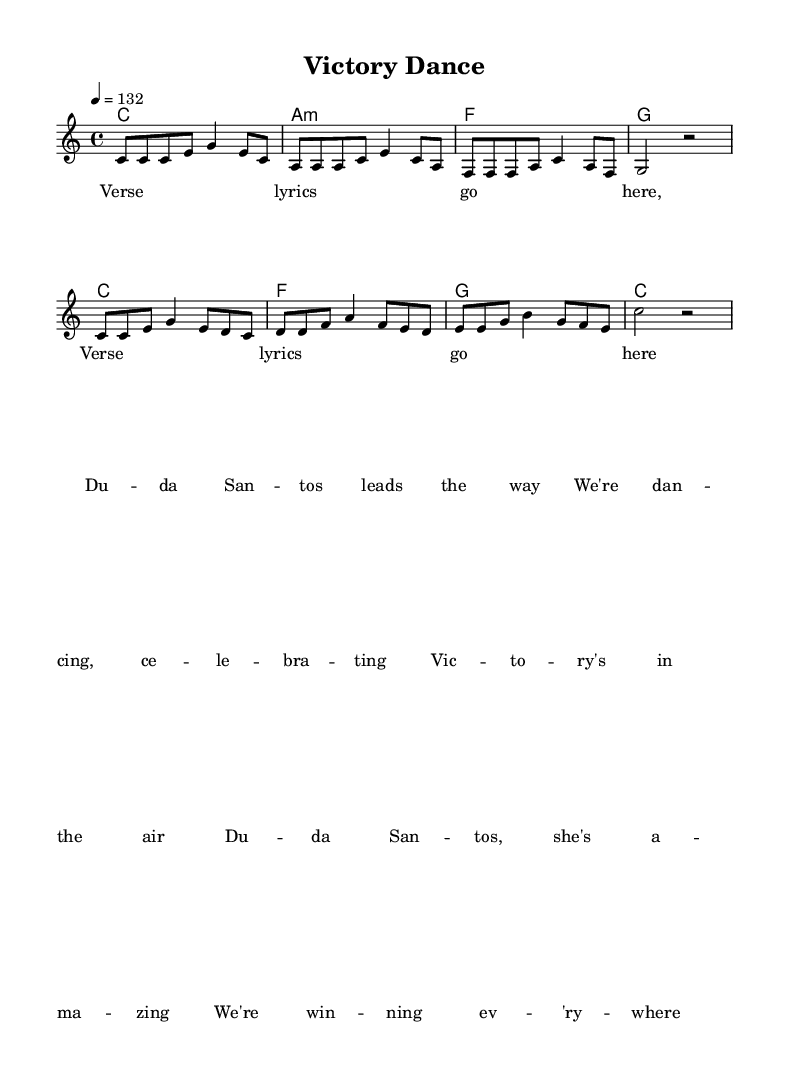What is the tempo marking of this music? The tempo marking is indicated at the beginning of the score as "4 = 132," which means there are 132 beats per minute at quarter note= 4.
Answer: 132 What is the time signature of this music? The time signature is indicated at the beginning of the score, represented as "4/4," meaning there are four beats in each measure and the quarter note gets one beat.
Answer: 4/4 What is the key signature of this music? The key signature is "C major," which has no sharps or flats, visible at the beginning of the score.
Answer: C major How many measures are in the verse section? Counting the measures outlined in the melody for the verse, we see there are 4 measures.
Answer: 4 What is the chord progression for the chorus? The chord progression for the chorus consists of "C, F, G, C," as indicated in the harmonies section for the chorus part.
Answer: C, F, G, C How many different chords are used in the verse? The verse uses three different chords: C major, A minor, F major, and G major, as shown in the harmonies section.
Answer: 4 What is the main theme of the lyrics? The lyrics focus on celebration and victory, which is a theme commonly associated with high-energy R&B songs, particularly in the context of post-match celebrations.
Answer: Celebration and victory 